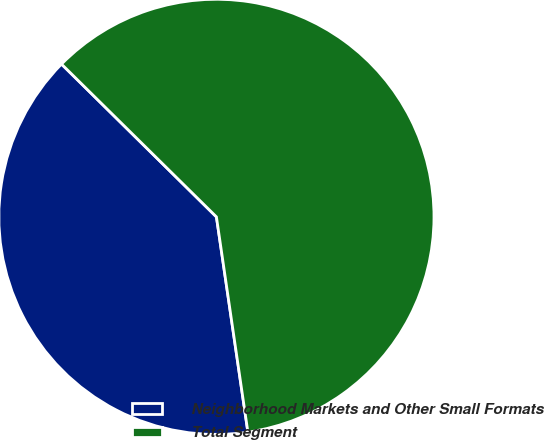Convert chart to OTSL. <chart><loc_0><loc_0><loc_500><loc_500><pie_chart><fcel>Neighborhood Markets and Other Small Formats<fcel>Total Segment<nl><fcel>39.7%<fcel>60.3%<nl></chart> 